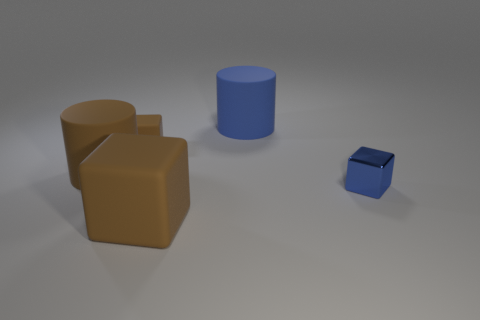Are there the same number of matte objects that are to the right of the large blue rubber cylinder and large brown cylinders?
Keep it short and to the point. No. There is a tiny blue thing; are there any tiny blue shiny blocks on the right side of it?
Ensure brevity in your answer.  No. How big is the brown matte cube that is behind the brown cube in front of the small blue metal object that is right of the blue cylinder?
Your response must be concise. Small. Does the large thing right of the big matte cube have the same shape as the blue object that is right of the blue cylinder?
Keep it short and to the point. No. There is another blue thing that is the same shape as the small rubber thing; what is its size?
Keep it short and to the point. Small. What number of other blue cylinders are made of the same material as the blue cylinder?
Provide a succinct answer. 0. What material is the blue cube?
Your answer should be very brief. Metal. What is the shape of the small object on the left side of the cylinder right of the brown rubber cylinder?
Keep it short and to the point. Cube. There is a big brown thing that is left of the small rubber thing; what is its shape?
Your answer should be compact. Cylinder. What number of other rubber cubes are the same color as the large cube?
Offer a terse response. 1. 